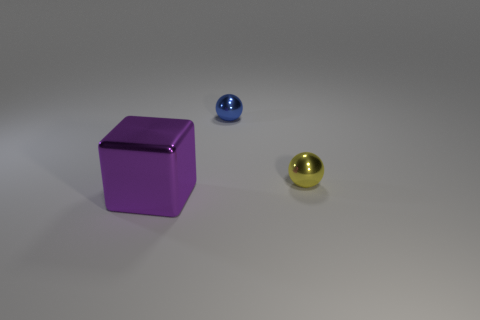There is a metallic sphere in front of the blue sphere; how big is it?
Give a very brief answer. Small. What material is the thing that is on the right side of the thing that is behind the small yellow sphere?
Keep it short and to the point. Metal. Are there fewer small purple things than tiny spheres?
Offer a terse response. Yes. There is a small ball left of the tiny yellow shiny thing; is there a tiny yellow metal ball right of it?
Your answer should be very brief. Yes. What shape is the large purple object that is the same material as the blue object?
Give a very brief answer. Cube. There is another object that is the same shape as the tiny blue metallic thing; what material is it?
Provide a short and direct response. Metal. How many other objects are there of the same size as the yellow metal ball?
Make the answer very short. 1. There is a tiny metal thing in front of the blue metal thing; does it have the same shape as the small blue thing?
Your answer should be compact. Yes. What number of other things are there of the same shape as the purple object?
Offer a very short reply. 0. The small object in front of the tiny blue object has what shape?
Your answer should be very brief. Sphere. 